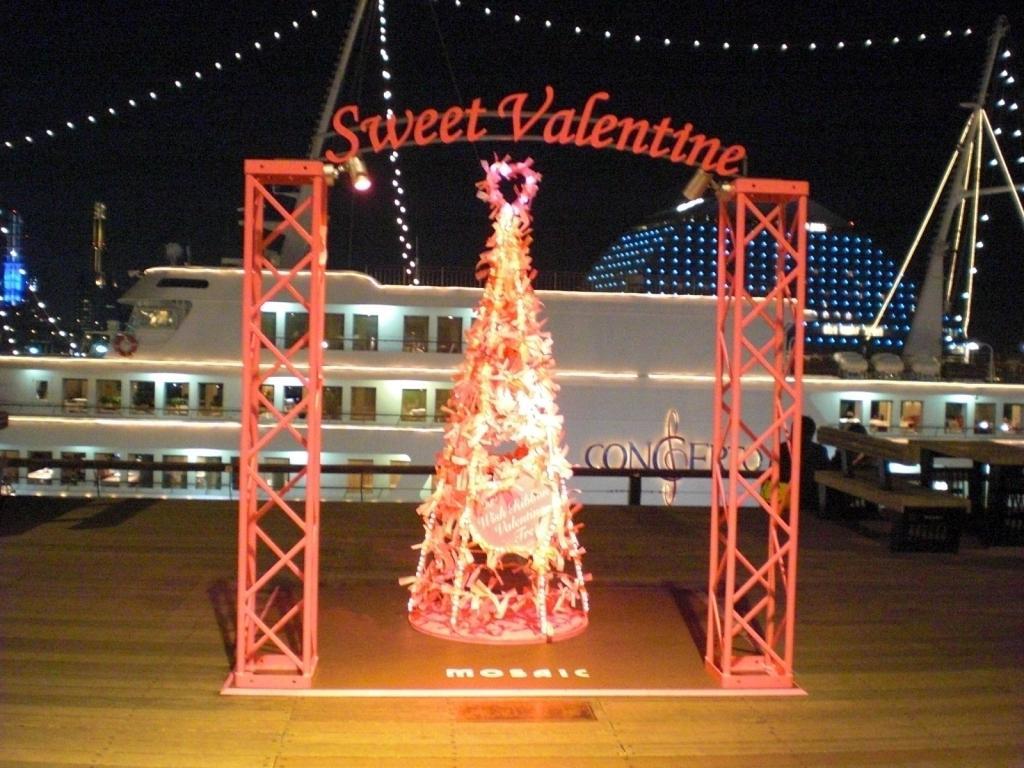How would you summarize this image in a sentence or two? In this image I can see there is a decorative object which is placed on the floor. Beside that, there is a stand with text. And there is a bench. And at the back there is a building with lights. And there are poles attached to the building. 